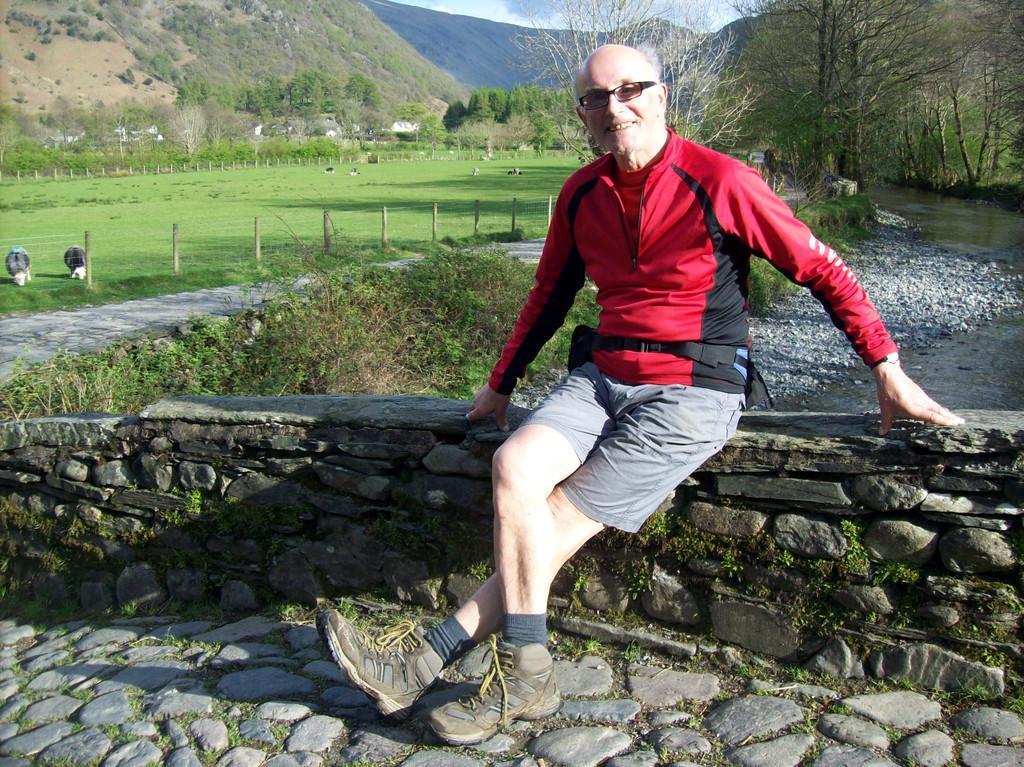Could you give a brief overview of what you see in this image? In this image we can see a man sitting on the wall and smiling and he is wearing spectacles and we can see some plants, trees and grass on the ground and we can see few animals. We can see the mountains in the background. 